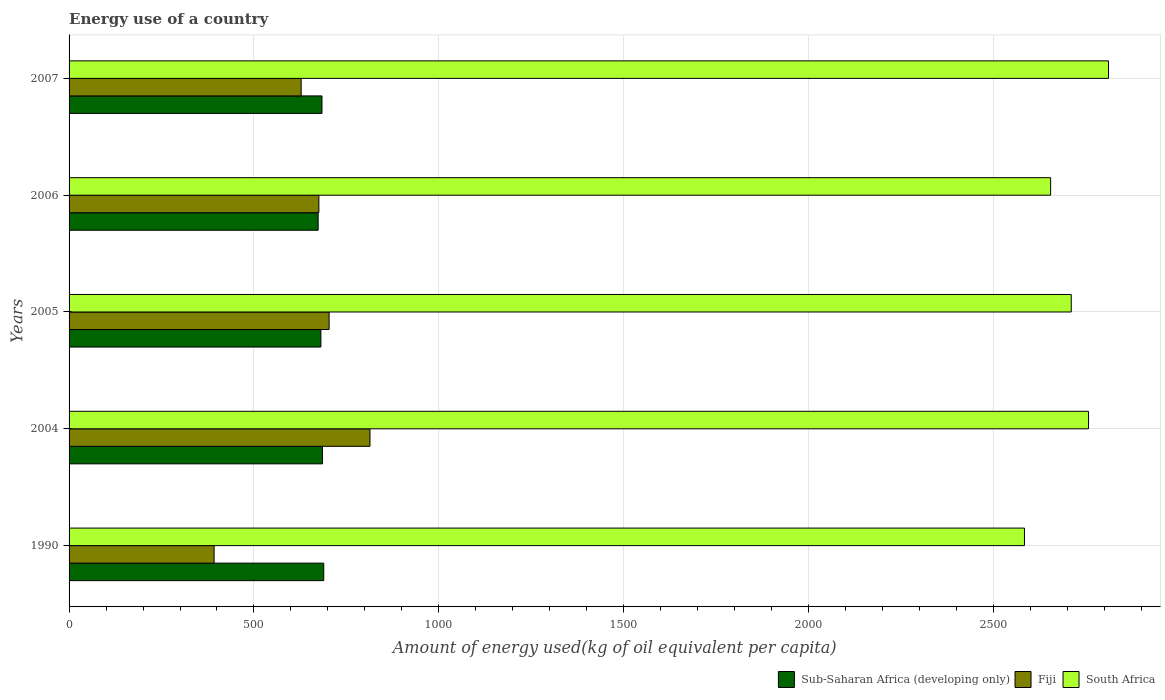How many different coloured bars are there?
Your answer should be very brief. 3. How many bars are there on the 1st tick from the bottom?
Provide a short and direct response. 3. What is the amount of energy used in in Fiji in 2007?
Provide a short and direct response. 627.75. Across all years, what is the maximum amount of energy used in in South Africa?
Offer a very short reply. 2811.28. Across all years, what is the minimum amount of energy used in in Fiji?
Give a very brief answer. 392.25. In which year was the amount of energy used in in Sub-Saharan Africa (developing only) maximum?
Give a very brief answer. 1990. What is the total amount of energy used in in Fiji in the graph?
Ensure brevity in your answer.  3212.77. What is the difference between the amount of energy used in in Fiji in 2005 and that in 2007?
Ensure brevity in your answer.  75.57. What is the difference between the amount of energy used in in Sub-Saharan Africa (developing only) in 1990 and the amount of energy used in in South Africa in 2005?
Provide a short and direct response. -2021.65. What is the average amount of energy used in in South Africa per year?
Your answer should be compact. 2703.55. In the year 2006, what is the difference between the amount of energy used in in South Africa and amount of energy used in in Fiji?
Your answer should be compact. 1979.14. What is the ratio of the amount of energy used in in South Africa in 2004 to that in 2007?
Ensure brevity in your answer.  0.98. Is the amount of energy used in in Fiji in 2005 less than that in 2006?
Offer a terse response. No. What is the difference between the highest and the second highest amount of energy used in in South Africa?
Provide a succinct answer. 54.03. What is the difference between the highest and the lowest amount of energy used in in Sub-Saharan Africa (developing only)?
Provide a succinct answer. 15.2. Is the sum of the amount of energy used in in Fiji in 2004 and 2007 greater than the maximum amount of energy used in in Sub-Saharan Africa (developing only) across all years?
Your response must be concise. Yes. What does the 3rd bar from the top in 2005 represents?
Give a very brief answer. Sub-Saharan Africa (developing only). What does the 3rd bar from the bottom in 2007 represents?
Provide a succinct answer. South Africa. Is it the case that in every year, the sum of the amount of energy used in in Fiji and amount of energy used in in South Africa is greater than the amount of energy used in in Sub-Saharan Africa (developing only)?
Your answer should be very brief. Yes. How many bars are there?
Offer a terse response. 15. Are all the bars in the graph horizontal?
Provide a succinct answer. Yes. How many years are there in the graph?
Ensure brevity in your answer.  5. What is the difference between two consecutive major ticks on the X-axis?
Offer a very short reply. 500. Are the values on the major ticks of X-axis written in scientific E-notation?
Give a very brief answer. No. Does the graph contain any zero values?
Your answer should be compact. No. Where does the legend appear in the graph?
Provide a succinct answer. Bottom right. What is the title of the graph?
Your answer should be very brief. Energy use of a country. What is the label or title of the X-axis?
Provide a succinct answer. Amount of energy used(kg of oil equivalent per capita). What is the label or title of the Y-axis?
Make the answer very short. Years. What is the Amount of energy used(kg of oil equivalent per capita) of Sub-Saharan Africa (developing only) in 1990?
Your answer should be compact. 688.81. What is the Amount of energy used(kg of oil equivalent per capita) of Fiji in 1990?
Offer a terse response. 392.25. What is the Amount of energy used(kg of oil equivalent per capita) of South Africa in 1990?
Ensure brevity in your answer.  2583.98. What is the Amount of energy used(kg of oil equivalent per capita) in Sub-Saharan Africa (developing only) in 2004?
Your answer should be compact. 685.23. What is the Amount of energy used(kg of oil equivalent per capita) of Fiji in 2004?
Provide a succinct answer. 813.83. What is the Amount of energy used(kg of oil equivalent per capita) of South Africa in 2004?
Ensure brevity in your answer.  2757.26. What is the Amount of energy used(kg of oil equivalent per capita) of Sub-Saharan Africa (developing only) in 2005?
Keep it short and to the point. 681.12. What is the Amount of energy used(kg of oil equivalent per capita) of Fiji in 2005?
Ensure brevity in your answer.  703.32. What is the Amount of energy used(kg of oil equivalent per capita) in South Africa in 2005?
Your answer should be compact. 2710.46. What is the Amount of energy used(kg of oil equivalent per capita) in Sub-Saharan Africa (developing only) in 2006?
Keep it short and to the point. 673.61. What is the Amount of energy used(kg of oil equivalent per capita) of Fiji in 2006?
Provide a short and direct response. 675.62. What is the Amount of energy used(kg of oil equivalent per capita) in South Africa in 2006?
Your answer should be compact. 2654.76. What is the Amount of energy used(kg of oil equivalent per capita) of Sub-Saharan Africa (developing only) in 2007?
Keep it short and to the point. 684.02. What is the Amount of energy used(kg of oil equivalent per capita) of Fiji in 2007?
Your answer should be compact. 627.75. What is the Amount of energy used(kg of oil equivalent per capita) of South Africa in 2007?
Give a very brief answer. 2811.28. Across all years, what is the maximum Amount of energy used(kg of oil equivalent per capita) of Sub-Saharan Africa (developing only)?
Ensure brevity in your answer.  688.81. Across all years, what is the maximum Amount of energy used(kg of oil equivalent per capita) of Fiji?
Ensure brevity in your answer.  813.83. Across all years, what is the maximum Amount of energy used(kg of oil equivalent per capita) of South Africa?
Provide a short and direct response. 2811.28. Across all years, what is the minimum Amount of energy used(kg of oil equivalent per capita) of Sub-Saharan Africa (developing only)?
Keep it short and to the point. 673.61. Across all years, what is the minimum Amount of energy used(kg of oil equivalent per capita) in Fiji?
Keep it short and to the point. 392.25. Across all years, what is the minimum Amount of energy used(kg of oil equivalent per capita) in South Africa?
Offer a terse response. 2583.98. What is the total Amount of energy used(kg of oil equivalent per capita) in Sub-Saharan Africa (developing only) in the graph?
Offer a terse response. 3412.8. What is the total Amount of energy used(kg of oil equivalent per capita) of Fiji in the graph?
Make the answer very short. 3212.77. What is the total Amount of energy used(kg of oil equivalent per capita) in South Africa in the graph?
Offer a terse response. 1.35e+04. What is the difference between the Amount of energy used(kg of oil equivalent per capita) of Sub-Saharan Africa (developing only) in 1990 and that in 2004?
Your answer should be very brief. 3.58. What is the difference between the Amount of energy used(kg of oil equivalent per capita) of Fiji in 1990 and that in 2004?
Provide a succinct answer. -421.57. What is the difference between the Amount of energy used(kg of oil equivalent per capita) of South Africa in 1990 and that in 2004?
Make the answer very short. -173.28. What is the difference between the Amount of energy used(kg of oil equivalent per capita) in Sub-Saharan Africa (developing only) in 1990 and that in 2005?
Offer a very short reply. 7.69. What is the difference between the Amount of energy used(kg of oil equivalent per capita) in Fiji in 1990 and that in 2005?
Ensure brevity in your answer.  -311.06. What is the difference between the Amount of energy used(kg of oil equivalent per capita) in South Africa in 1990 and that in 2005?
Offer a very short reply. -126.48. What is the difference between the Amount of energy used(kg of oil equivalent per capita) in Sub-Saharan Africa (developing only) in 1990 and that in 2006?
Provide a succinct answer. 15.2. What is the difference between the Amount of energy used(kg of oil equivalent per capita) of Fiji in 1990 and that in 2006?
Your response must be concise. -283.36. What is the difference between the Amount of energy used(kg of oil equivalent per capita) of South Africa in 1990 and that in 2006?
Make the answer very short. -70.78. What is the difference between the Amount of energy used(kg of oil equivalent per capita) in Sub-Saharan Africa (developing only) in 1990 and that in 2007?
Make the answer very short. 4.79. What is the difference between the Amount of energy used(kg of oil equivalent per capita) in Fiji in 1990 and that in 2007?
Ensure brevity in your answer.  -235.5. What is the difference between the Amount of energy used(kg of oil equivalent per capita) in South Africa in 1990 and that in 2007?
Keep it short and to the point. -227.3. What is the difference between the Amount of energy used(kg of oil equivalent per capita) in Sub-Saharan Africa (developing only) in 2004 and that in 2005?
Keep it short and to the point. 4.11. What is the difference between the Amount of energy used(kg of oil equivalent per capita) of Fiji in 2004 and that in 2005?
Offer a terse response. 110.51. What is the difference between the Amount of energy used(kg of oil equivalent per capita) in South Africa in 2004 and that in 2005?
Your response must be concise. 46.79. What is the difference between the Amount of energy used(kg of oil equivalent per capita) in Sub-Saharan Africa (developing only) in 2004 and that in 2006?
Offer a terse response. 11.62. What is the difference between the Amount of energy used(kg of oil equivalent per capita) in Fiji in 2004 and that in 2006?
Your answer should be very brief. 138.21. What is the difference between the Amount of energy used(kg of oil equivalent per capita) in South Africa in 2004 and that in 2006?
Provide a succinct answer. 102.49. What is the difference between the Amount of energy used(kg of oil equivalent per capita) of Sub-Saharan Africa (developing only) in 2004 and that in 2007?
Your response must be concise. 1.21. What is the difference between the Amount of energy used(kg of oil equivalent per capita) in Fiji in 2004 and that in 2007?
Provide a short and direct response. 186.08. What is the difference between the Amount of energy used(kg of oil equivalent per capita) of South Africa in 2004 and that in 2007?
Provide a succinct answer. -54.03. What is the difference between the Amount of energy used(kg of oil equivalent per capita) of Sub-Saharan Africa (developing only) in 2005 and that in 2006?
Your answer should be very brief. 7.51. What is the difference between the Amount of energy used(kg of oil equivalent per capita) of Fiji in 2005 and that in 2006?
Provide a short and direct response. 27.7. What is the difference between the Amount of energy used(kg of oil equivalent per capita) in South Africa in 2005 and that in 2006?
Give a very brief answer. 55.7. What is the difference between the Amount of energy used(kg of oil equivalent per capita) in Sub-Saharan Africa (developing only) in 2005 and that in 2007?
Your answer should be very brief. -2.9. What is the difference between the Amount of energy used(kg of oil equivalent per capita) of Fiji in 2005 and that in 2007?
Offer a very short reply. 75.57. What is the difference between the Amount of energy used(kg of oil equivalent per capita) of South Africa in 2005 and that in 2007?
Make the answer very short. -100.82. What is the difference between the Amount of energy used(kg of oil equivalent per capita) of Sub-Saharan Africa (developing only) in 2006 and that in 2007?
Offer a very short reply. -10.41. What is the difference between the Amount of energy used(kg of oil equivalent per capita) of Fiji in 2006 and that in 2007?
Provide a succinct answer. 47.87. What is the difference between the Amount of energy used(kg of oil equivalent per capita) of South Africa in 2006 and that in 2007?
Give a very brief answer. -156.52. What is the difference between the Amount of energy used(kg of oil equivalent per capita) of Sub-Saharan Africa (developing only) in 1990 and the Amount of energy used(kg of oil equivalent per capita) of Fiji in 2004?
Make the answer very short. -125.02. What is the difference between the Amount of energy used(kg of oil equivalent per capita) in Sub-Saharan Africa (developing only) in 1990 and the Amount of energy used(kg of oil equivalent per capita) in South Africa in 2004?
Give a very brief answer. -2068.45. What is the difference between the Amount of energy used(kg of oil equivalent per capita) in Fiji in 1990 and the Amount of energy used(kg of oil equivalent per capita) in South Africa in 2004?
Ensure brevity in your answer.  -2365. What is the difference between the Amount of energy used(kg of oil equivalent per capita) in Sub-Saharan Africa (developing only) in 1990 and the Amount of energy used(kg of oil equivalent per capita) in Fiji in 2005?
Your answer should be compact. -14.51. What is the difference between the Amount of energy used(kg of oil equivalent per capita) of Sub-Saharan Africa (developing only) in 1990 and the Amount of energy used(kg of oil equivalent per capita) of South Africa in 2005?
Your answer should be very brief. -2021.65. What is the difference between the Amount of energy used(kg of oil equivalent per capita) of Fiji in 1990 and the Amount of energy used(kg of oil equivalent per capita) of South Africa in 2005?
Your answer should be compact. -2318.21. What is the difference between the Amount of energy used(kg of oil equivalent per capita) in Sub-Saharan Africa (developing only) in 1990 and the Amount of energy used(kg of oil equivalent per capita) in Fiji in 2006?
Your answer should be compact. 13.19. What is the difference between the Amount of energy used(kg of oil equivalent per capita) of Sub-Saharan Africa (developing only) in 1990 and the Amount of energy used(kg of oil equivalent per capita) of South Africa in 2006?
Offer a terse response. -1965.95. What is the difference between the Amount of energy used(kg of oil equivalent per capita) of Fiji in 1990 and the Amount of energy used(kg of oil equivalent per capita) of South Africa in 2006?
Make the answer very short. -2262.51. What is the difference between the Amount of energy used(kg of oil equivalent per capita) of Sub-Saharan Africa (developing only) in 1990 and the Amount of energy used(kg of oil equivalent per capita) of Fiji in 2007?
Provide a succinct answer. 61.06. What is the difference between the Amount of energy used(kg of oil equivalent per capita) in Sub-Saharan Africa (developing only) in 1990 and the Amount of energy used(kg of oil equivalent per capita) in South Africa in 2007?
Offer a very short reply. -2122.47. What is the difference between the Amount of energy used(kg of oil equivalent per capita) in Fiji in 1990 and the Amount of energy used(kg of oil equivalent per capita) in South Africa in 2007?
Provide a short and direct response. -2419.03. What is the difference between the Amount of energy used(kg of oil equivalent per capita) of Sub-Saharan Africa (developing only) in 2004 and the Amount of energy used(kg of oil equivalent per capita) of Fiji in 2005?
Your answer should be compact. -18.09. What is the difference between the Amount of energy used(kg of oil equivalent per capita) of Sub-Saharan Africa (developing only) in 2004 and the Amount of energy used(kg of oil equivalent per capita) of South Africa in 2005?
Offer a terse response. -2025.23. What is the difference between the Amount of energy used(kg of oil equivalent per capita) of Fiji in 2004 and the Amount of energy used(kg of oil equivalent per capita) of South Africa in 2005?
Give a very brief answer. -1896.63. What is the difference between the Amount of energy used(kg of oil equivalent per capita) in Sub-Saharan Africa (developing only) in 2004 and the Amount of energy used(kg of oil equivalent per capita) in Fiji in 2006?
Provide a succinct answer. 9.61. What is the difference between the Amount of energy used(kg of oil equivalent per capita) of Sub-Saharan Africa (developing only) in 2004 and the Amount of energy used(kg of oil equivalent per capita) of South Africa in 2006?
Offer a very short reply. -1969.53. What is the difference between the Amount of energy used(kg of oil equivalent per capita) in Fiji in 2004 and the Amount of energy used(kg of oil equivalent per capita) in South Africa in 2006?
Your response must be concise. -1840.93. What is the difference between the Amount of energy used(kg of oil equivalent per capita) in Sub-Saharan Africa (developing only) in 2004 and the Amount of energy used(kg of oil equivalent per capita) in Fiji in 2007?
Provide a succinct answer. 57.48. What is the difference between the Amount of energy used(kg of oil equivalent per capita) of Sub-Saharan Africa (developing only) in 2004 and the Amount of energy used(kg of oil equivalent per capita) of South Africa in 2007?
Your response must be concise. -2126.05. What is the difference between the Amount of energy used(kg of oil equivalent per capita) in Fiji in 2004 and the Amount of energy used(kg of oil equivalent per capita) in South Africa in 2007?
Your answer should be compact. -1997.45. What is the difference between the Amount of energy used(kg of oil equivalent per capita) of Sub-Saharan Africa (developing only) in 2005 and the Amount of energy used(kg of oil equivalent per capita) of Fiji in 2006?
Provide a succinct answer. 5.5. What is the difference between the Amount of energy used(kg of oil equivalent per capita) of Sub-Saharan Africa (developing only) in 2005 and the Amount of energy used(kg of oil equivalent per capita) of South Africa in 2006?
Ensure brevity in your answer.  -1973.64. What is the difference between the Amount of energy used(kg of oil equivalent per capita) of Fiji in 2005 and the Amount of energy used(kg of oil equivalent per capita) of South Africa in 2006?
Your response must be concise. -1951.45. What is the difference between the Amount of energy used(kg of oil equivalent per capita) in Sub-Saharan Africa (developing only) in 2005 and the Amount of energy used(kg of oil equivalent per capita) in Fiji in 2007?
Give a very brief answer. 53.37. What is the difference between the Amount of energy used(kg of oil equivalent per capita) of Sub-Saharan Africa (developing only) in 2005 and the Amount of energy used(kg of oil equivalent per capita) of South Africa in 2007?
Offer a very short reply. -2130.16. What is the difference between the Amount of energy used(kg of oil equivalent per capita) of Fiji in 2005 and the Amount of energy used(kg of oil equivalent per capita) of South Africa in 2007?
Provide a short and direct response. -2107.96. What is the difference between the Amount of energy used(kg of oil equivalent per capita) in Sub-Saharan Africa (developing only) in 2006 and the Amount of energy used(kg of oil equivalent per capita) in Fiji in 2007?
Provide a succinct answer. 45.87. What is the difference between the Amount of energy used(kg of oil equivalent per capita) of Sub-Saharan Africa (developing only) in 2006 and the Amount of energy used(kg of oil equivalent per capita) of South Africa in 2007?
Your answer should be very brief. -2137.67. What is the difference between the Amount of energy used(kg of oil equivalent per capita) in Fiji in 2006 and the Amount of energy used(kg of oil equivalent per capita) in South Africa in 2007?
Offer a terse response. -2135.66. What is the average Amount of energy used(kg of oil equivalent per capita) of Sub-Saharan Africa (developing only) per year?
Make the answer very short. 682.56. What is the average Amount of energy used(kg of oil equivalent per capita) of Fiji per year?
Provide a short and direct response. 642.55. What is the average Amount of energy used(kg of oil equivalent per capita) in South Africa per year?
Give a very brief answer. 2703.55. In the year 1990, what is the difference between the Amount of energy used(kg of oil equivalent per capita) in Sub-Saharan Africa (developing only) and Amount of energy used(kg of oil equivalent per capita) in Fiji?
Make the answer very short. 296.56. In the year 1990, what is the difference between the Amount of energy used(kg of oil equivalent per capita) of Sub-Saharan Africa (developing only) and Amount of energy used(kg of oil equivalent per capita) of South Africa?
Make the answer very short. -1895.17. In the year 1990, what is the difference between the Amount of energy used(kg of oil equivalent per capita) of Fiji and Amount of energy used(kg of oil equivalent per capita) of South Africa?
Offer a terse response. -2191.73. In the year 2004, what is the difference between the Amount of energy used(kg of oil equivalent per capita) in Sub-Saharan Africa (developing only) and Amount of energy used(kg of oil equivalent per capita) in Fiji?
Your answer should be very brief. -128.6. In the year 2004, what is the difference between the Amount of energy used(kg of oil equivalent per capita) of Sub-Saharan Africa (developing only) and Amount of energy used(kg of oil equivalent per capita) of South Africa?
Offer a very short reply. -2072.02. In the year 2004, what is the difference between the Amount of energy used(kg of oil equivalent per capita) of Fiji and Amount of energy used(kg of oil equivalent per capita) of South Africa?
Make the answer very short. -1943.43. In the year 2005, what is the difference between the Amount of energy used(kg of oil equivalent per capita) of Sub-Saharan Africa (developing only) and Amount of energy used(kg of oil equivalent per capita) of Fiji?
Provide a succinct answer. -22.2. In the year 2005, what is the difference between the Amount of energy used(kg of oil equivalent per capita) of Sub-Saharan Africa (developing only) and Amount of energy used(kg of oil equivalent per capita) of South Africa?
Give a very brief answer. -2029.34. In the year 2005, what is the difference between the Amount of energy used(kg of oil equivalent per capita) in Fiji and Amount of energy used(kg of oil equivalent per capita) in South Africa?
Make the answer very short. -2007.15. In the year 2006, what is the difference between the Amount of energy used(kg of oil equivalent per capita) of Sub-Saharan Africa (developing only) and Amount of energy used(kg of oil equivalent per capita) of Fiji?
Ensure brevity in your answer.  -2. In the year 2006, what is the difference between the Amount of energy used(kg of oil equivalent per capita) of Sub-Saharan Africa (developing only) and Amount of energy used(kg of oil equivalent per capita) of South Africa?
Give a very brief answer. -1981.15. In the year 2006, what is the difference between the Amount of energy used(kg of oil equivalent per capita) of Fiji and Amount of energy used(kg of oil equivalent per capita) of South Africa?
Your answer should be compact. -1979.14. In the year 2007, what is the difference between the Amount of energy used(kg of oil equivalent per capita) of Sub-Saharan Africa (developing only) and Amount of energy used(kg of oil equivalent per capita) of Fiji?
Offer a very short reply. 56.27. In the year 2007, what is the difference between the Amount of energy used(kg of oil equivalent per capita) in Sub-Saharan Africa (developing only) and Amount of energy used(kg of oil equivalent per capita) in South Africa?
Your answer should be very brief. -2127.26. In the year 2007, what is the difference between the Amount of energy used(kg of oil equivalent per capita) of Fiji and Amount of energy used(kg of oil equivalent per capita) of South Africa?
Ensure brevity in your answer.  -2183.53. What is the ratio of the Amount of energy used(kg of oil equivalent per capita) in Fiji in 1990 to that in 2004?
Your response must be concise. 0.48. What is the ratio of the Amount of energy used(kg of oil equivalent per capita) in South Africa in 1990 to that in 2004?
Offer a terse response. 0.94. What is the ratio of the Amount of energy used(kg of oil equivalent per capita) in Sub-Saharan Africa (developing only) in 1990 to that in 2005?
Keep it short and to the point. 1.01. What is the ratio of the Amount of energy used(kg of oil equivalent per capita) in Fiji in 1990 to that in 2005?
Your response must be concise. 0.56. What is the ratio of the Amount of energy used(kg of oil equivalent per capita) in South Africa in 1990 to that in 2005?
Provide a short and direct response. 0.95. What is the ratio of the Amount of energy used(kg of oil equivalent per capita) of Sub-Saharan Africa (developing only) in 1990 to that in 2006?
Your response must be concise. 1.02. What is the ratio of the Amount of energy used(kg of oil equivalent per capita) in Fiji in 1990 to that in 2006?
Your response must be concise. 0.58. What is the ratio of the Amount of energy used(kg of oil equivalent per capita) in South Africa in 1990 to that in 2006?
Provide a succinct answer. 0.97. What is the ratio of the Amount of energy used(kg of oil equivalent per capita) of Fiji in 1990 to that in 2007?
Provide a short and direct response. 0.62. What is the ratio of the Amount of energy used(kg of oil equivalent per capita) of South Africa in 1990 to that in 2007?
Your response must be concise. 0.92. What is the ratio of the Amount of energy used(kg of oil equivalent per capita) of Sub-Saharan Africa (developing only) in 2004 to that in 2005?
Keep it short and to the point. 1.01. What is the ratio of the Amount of energy used(kg of oil equivalent per capita) in Fiji in 2004 to that in 2005?
Give a very brief answer. 1.16. What is the ratio of the Amount of energy used(kg of oil equivalent per capita) in South Africa in 2004 to that in 2005?
Ensure brevity in your answer.  1.02. What is the ratio of the Amount of energy used(kg of oil equivalent per capita) of Sub-Saharan Africa (developing only) in 2004 to that in 2006?
Your response must be concise. 1.02. What is the ratio of the Amount of energy used(kg of oil equivalent per capita) of Fiji in 2004 to that in 2006?
Provide a succinct answer. 1.2. What is the ratio of the Amount of energy used(kg of oil equivalent per capita) in South Africa in 2004 to that in 2006?
Provide a short and direct response. 1.04. What is the ratio of the Amount of energy used(kg of oil equivalent per capita) of Fiji in 2004 to that in 2007?
Make the answer very short. 1.3. What is the ratio of the Amount of energy used(kg of oil equivalent per capita) of South Africa in 2004 to that in 2007?
Provide a succinct answer. 0.98. What is the ratio of the Amount of energy used(kg of oil equivalent per capita) of Sub-Saharan Africa (developing only) in 2005 to that in 2006?
Provide a short and direct response. 1.01. What is the ratio of the Amount of energy used(kg of oil equivalent per capita) in Fiji in 2005 to that in 2006?
Offer a terse response. 1.04. What is the ratio of the Amount of energy used(kg of oil equivalent per capita) of South Africa in 2005 to that in 2006?
Make the answer very short. 1.02. What is the ratio of the Amount of energy used(kg of oil equivalent per capita) of Sub-Saharan Africa (developing only) in 2005 to that in 2007?
Your answer should be compact. 1. What is the ratio of the Amount of energy used(kg of oil equivalent per capita) in Fiji in 2005 to that in 2007?
Offer a very short reply. 1.12. What is the ratio of the Amount of energy used(kg of oil equivalent per capita) of South Africa in 2005 to that in 2007?
Provide a short and direct response. 0.96. What is the ratio of the Amount of energy used(kg of oil equivalent per capita) in Sub-Saharan Africa (developing only) in 2006 to that in 2007?
Provide a succinct answer. 0.98. What is the ratio of the Amount of energy used(kg of oil equivalent per capita) of Fiji in 2006 to that in 2007?
Offer a very short reply. 1.08. What is the ratio of the Amount of energy used(kg of oil equivalent per capita) in South Africa in 2006 to that in 2007?
Keep it short and to the point. 0.94. What is the difference between the highest and the second highest Amount of energy used(kg of oil equivalent per capita) in Sub-Saharan Africa (developing only)?
Offer a terse response. 3.58. What is the difference between the highest and the second highest Amount of energy used(kg of oil equivalent per capita) in Fiji?
Offer a terse response. 110.51. What is the difference between the highest and the second highest Amount of energy used(kg of oil equivalent per capita) of South Africa?
Offer a terse response. 54.03. What is the difference between the highest and the lowest Amount of energy used(kg of oil equivalent per capita) of Sub-Saharan Africa (developing only)?
Your answer should be compact. 15.2. What is the difference between the highest and the lowest Amount of energy used(kg of oil equivalent per capita) of Fiji?
Keep it short and to the point. 421.57. What is the difference between the highest and the lowest Amount of energy used(kg of oil equivalent per capita) in South Africa?
Give a very brief answer. 227.3. 